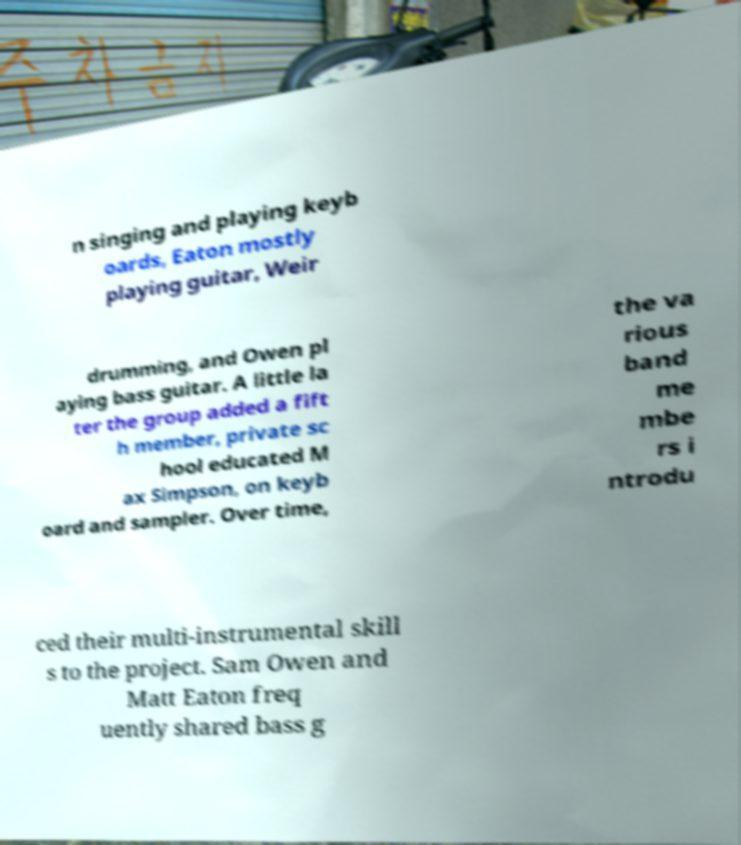Could you extract and type out the text from this image? n singing and playing keyb oards, Eaton mostly playing guitar, Weir drumming, and Owen pl aying bass guitar. A little la ter the group added a fift h member, private sc hool educated M ax Simpson, on keyb oard and sampler. Over time, the va rious band me mbe rs i ntrodu ced their multi-instrumental skill s to the project. Sam Owen and Matt Eaton freq uently shared bass g 